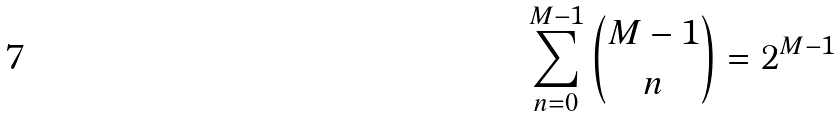Convert formula to latex. <formula><loc_0><loc_0><loc_500><loc_500>\sum _ { n = 0 } ^ { M - 1 } \binom { M - 1 } { n } = 2 ^ { M - 1 }</formula> 